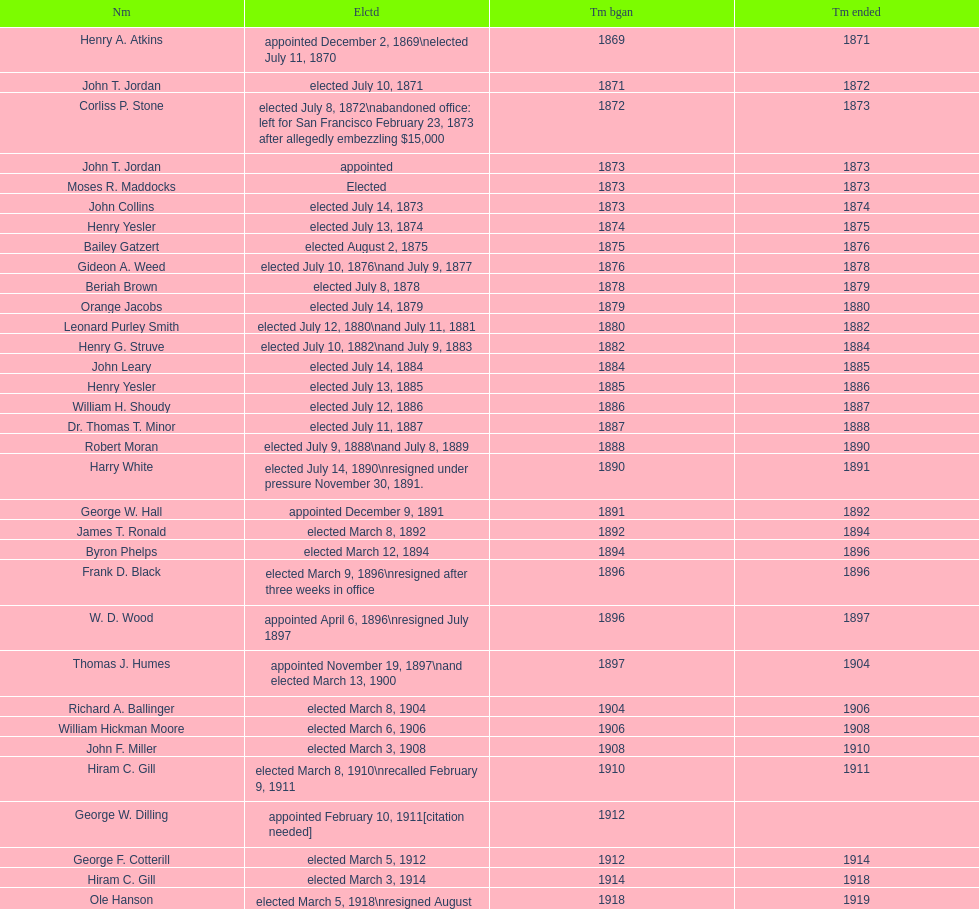Who was the unique person that got elected in the year 1871? John T. Jordan. 